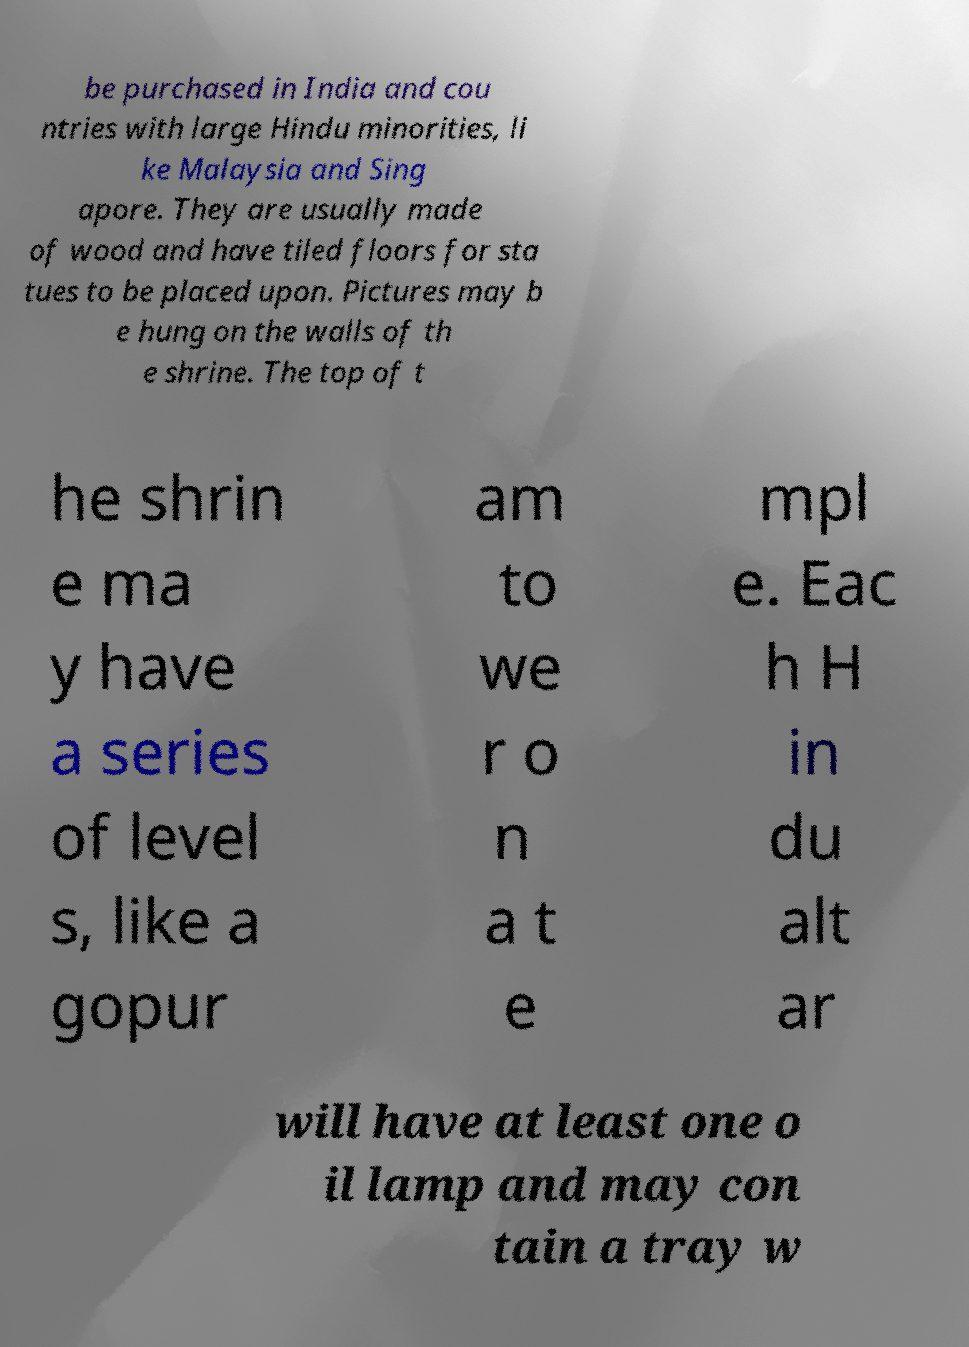For documentation purposes, I need the text within this image transcribed. Could you provide that? be purchased in India and cou ntries with large Hindu minorities, li ke Malaysia and Sing apore. They are usually made of wood and have tiled floors for sta tues to be placed upon. Pictures may b e hung on the walls of th e shrine. The top of t he shrin e ma y have a series of level s, like a gopur am to we r o n a t e mpl e. Eac h H in du alt ar will have at least one o il lamp and may con tain a tray w 